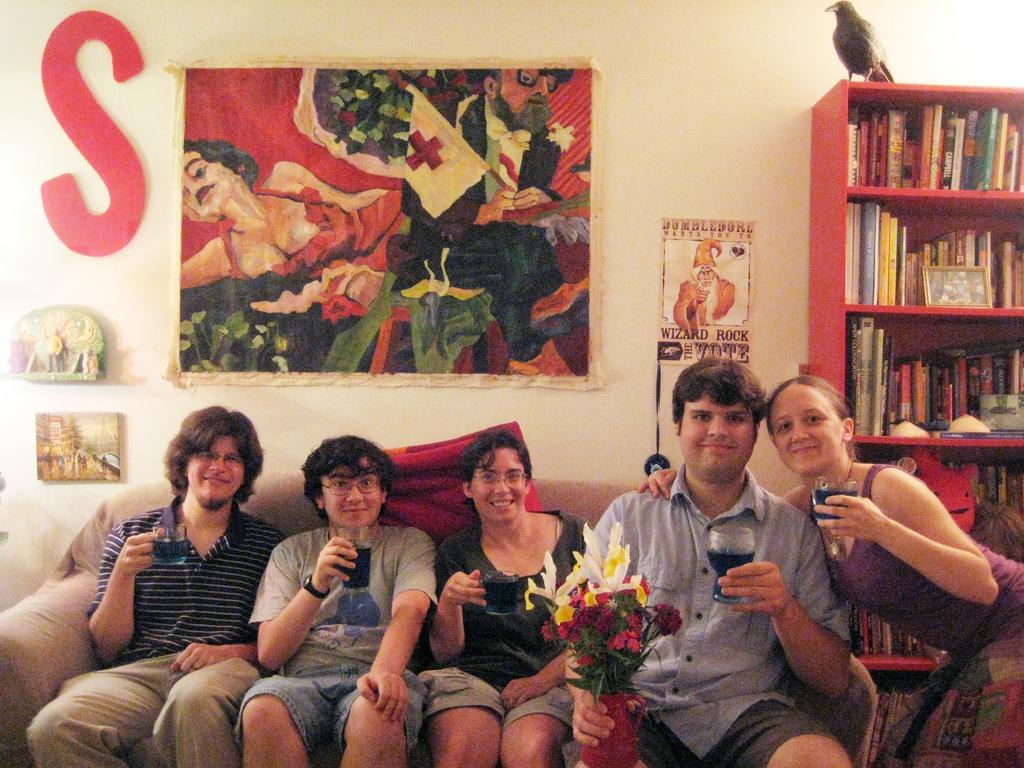Could you give a brief overview of what you see in this image? In this image, there are five persons in different color dresses, smiling and holding glasses which are filled with drink. Four of them are sitting. One of the rest is bending and placing a hand on the shoulder of a person who is holding a flower vase. In the background, there are books arranged on the shelves of a cupboard. On top of this cupboard, there is a bird. Beside this cupboard, there are paintings pasted on the wall. 